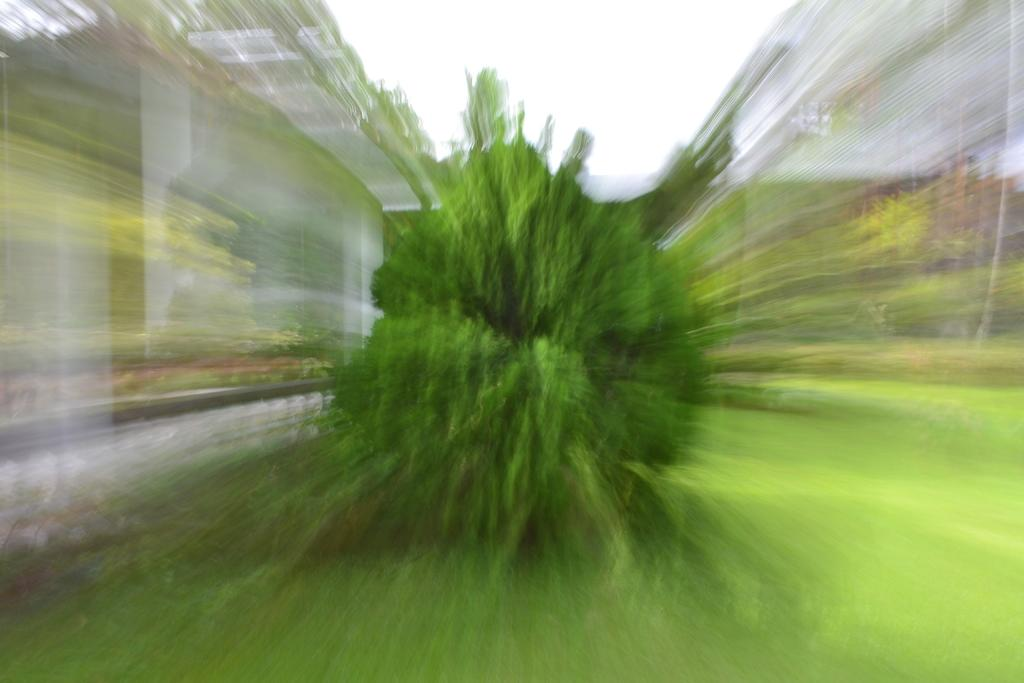What is present in the image? There is a plant in the image. What can be seen in the background of the image? The sky is visible in the image. Can you describe the edges of the image? The corners of the image are blurred. What type of pleasure can be seen on the crow's face in the image? There is no crow present in the image, so it is not possible to determine the pleasure on its face. 